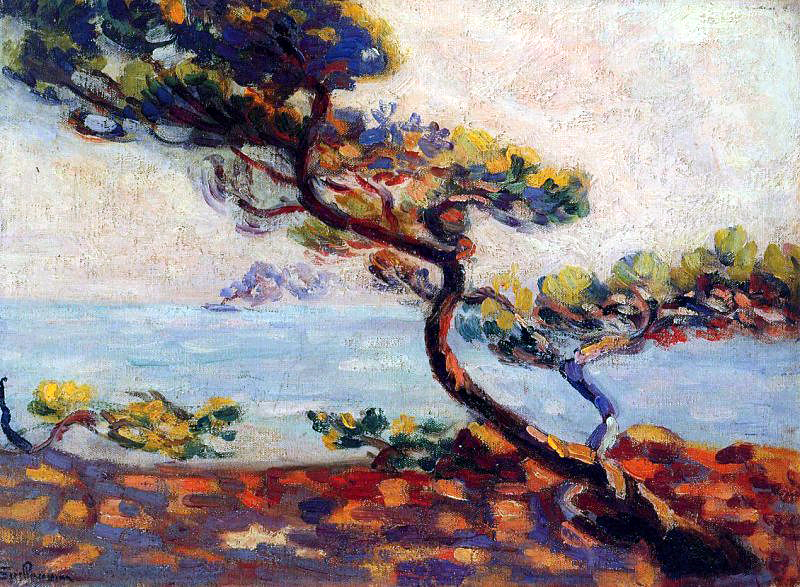What if the tree in the painting could speak? What do you think it would say? If the tree could speak, it might say: 'I have stood here for centuries, witnessing the ebb and flow of the tides and the blossoming and fading of countless seasons. I have felt the sun's warm embrace, the kiss of the gentle breeze, and the battering of fierce storms. Many have come and gone, seeking solace and inspiration under my shade. My branches have danced in the winds and have cradled nests, harboring life and love. I am a steadfast guardian of this shore, a symbol of endurance and grace amidst the ever-changing world.' 